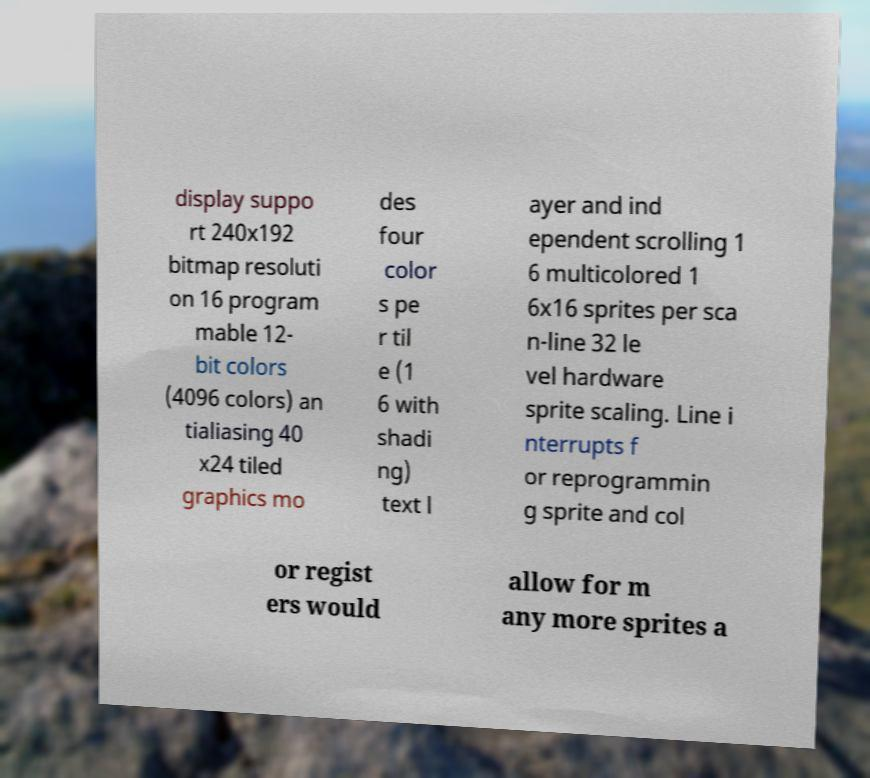There's text embedded in this image that I need extracted. Can you transcribe it verbatim? display suppo rt 240x192 bitmap resoluti on 16 program mable 12- bit colors (4096 colors) an tialiasing 40 x24 tiled graphics mo des four color s pe r til e (1 6 with shadi ng) text l ayer and ind ependent scrolling 1 6 multicolored 1 6x16 sprites per sca n-line 32 le vel hardware sprite scaling. Line i nterrupts f or reprogrammin g sprite and col or regist ers would allow for m any more sprites a 